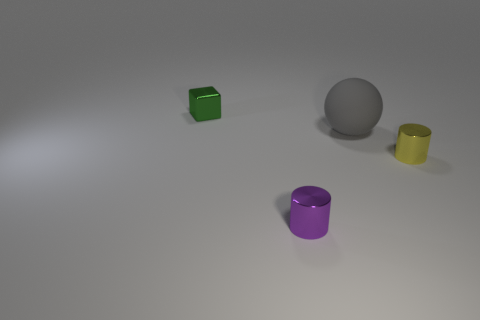Add 1 large rubber balls. How many objects exist? 5 Subtract all balls. How many objects are left? 3 Subtract 1 gray spheres. How many objects are left? 3 Subtract all tiny green cubes. Subtract all purple metallic things. How many objects are left? 2 Add 1 small purple shiny objects. How many small purple shiny objects are left? 2 Add 4 green objects. How many green objects exist? 5 